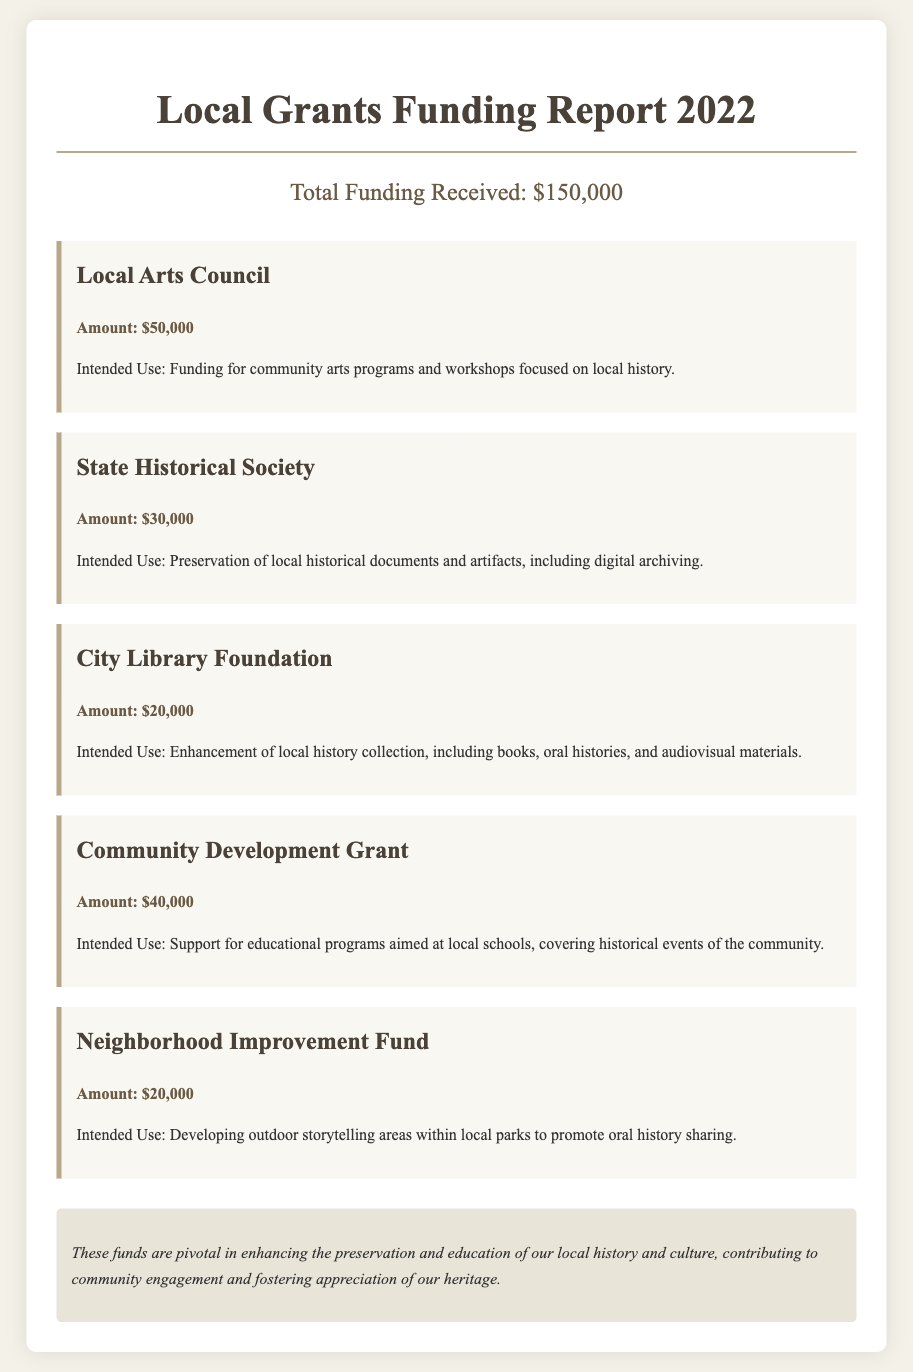what was the total funding received? The total funding is stated clearly in the document as $150,000.
Answer: $150,000 how much funding did the Local Arts Council receive? The document specifies that the Local Arts Council received $50,000.
Answer: $50,000 what was the intended use of the funds from the City Library Foundation? The intended use for the City Library Foundation funds is to enhance the local history collection, including books, oral histories, and audiovisual materials.
Answer: Enhancement of local history collection how much money was allocated for the preservation of local historical documents? The amount allocated for the preservation of local historical documents and artifacts by the State Historical Society is stated as $30,000.
Answer: $30,000 which grant was aimed at developing outdoor storytelling areas? The Neighborhood Improvement Fund was aimed at developing outdoor storytelling areas within local parks.
Answer: Neighborhood Improvement Fund how many different funding sources are listed in the report? The document lists five distinct funding sources: Local Arts Council, State Historical Society, City Library Foundation, Community Development Grant, and Neighborhood Improvement Fund.
Answer: Five what is the total amount allocated for community educational programs? The Community Development Grant provided $40,000 for educational programs aimed at local schools.
Answer: $40,000 which funding source focuses specifically on community arts programs? The Local Arts Council focuses on funding community arts programs and workshops.
Answer: Local Arts Council 